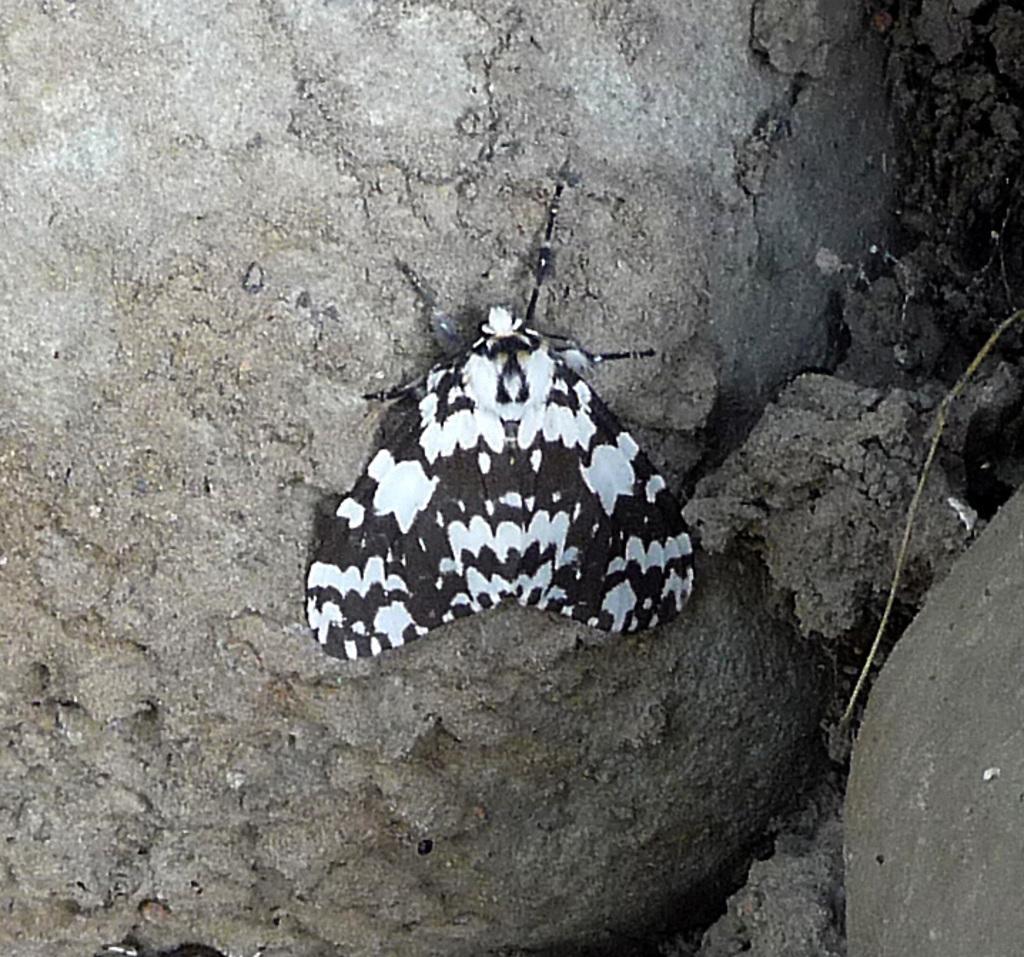Describe this image in one or two sentences. In this image I can see an insect is on the rock surface. 